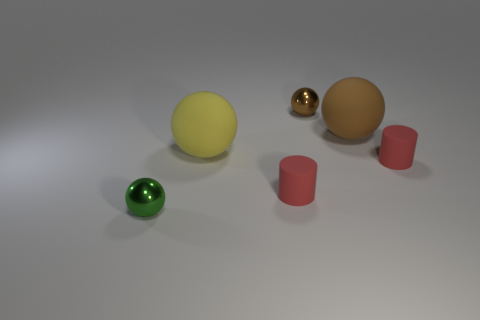Subtract all purple blocks. How many brown spheres are left? 2 Subtract all tiny brown metal balls. How many balls are left? 3 Add 3 large metal things. How many objects exist? 9 Subtract all green spheres. How many spheres are left? 3 Add 5 yellow spheres. How many yellow spheres are left? 6 Add 4 small brown shiny balls. How many small brown shiny balls exist? 5 Subtract 0 gray cubes. How many objects are left? 6 Subtract all spheres. How many objects are left? 2 Subtract all yellow balls. Subtract all red cylinders. How many balls are left? 3 Subtract all brown matte cylinders. Subtract all matte things. How many objects are left? 2 